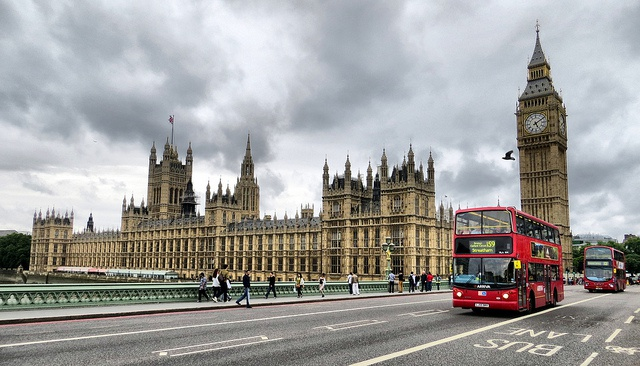Describe the objects in this image and their specific colors. I can see bus in darkgray, black, gray, brown, and maroon tones, bus in darkgray, black, gray, and maroon tones, people in darkgray, black, and gray tones, clock in darkgray, gray, and black tones, and people in darkgray, black, gray, and navy tones in this image. 